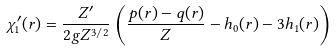Convert formula to latex. <formula><loc_0><loc_0><loc_500><loc_500>\chi _ { 1 } ^ { \prime } ( r ) = \frac { Z ^ { \prime } } { 2 g Z ^ { 3 / 2 } } \left ( \frac { p ( r ) - q ( r ) } { Z } - h _ { 0 } ( r ) - 3 h _ { 1 } ( r ) \right )</formula> 